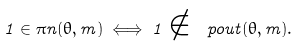<formula> <loc_0><loc_0><loc_500><loc_500>1 \in \pi n ( \theta , m ) \iff 1 \notin \ p o u t ( \theta , m ) .</formula> 